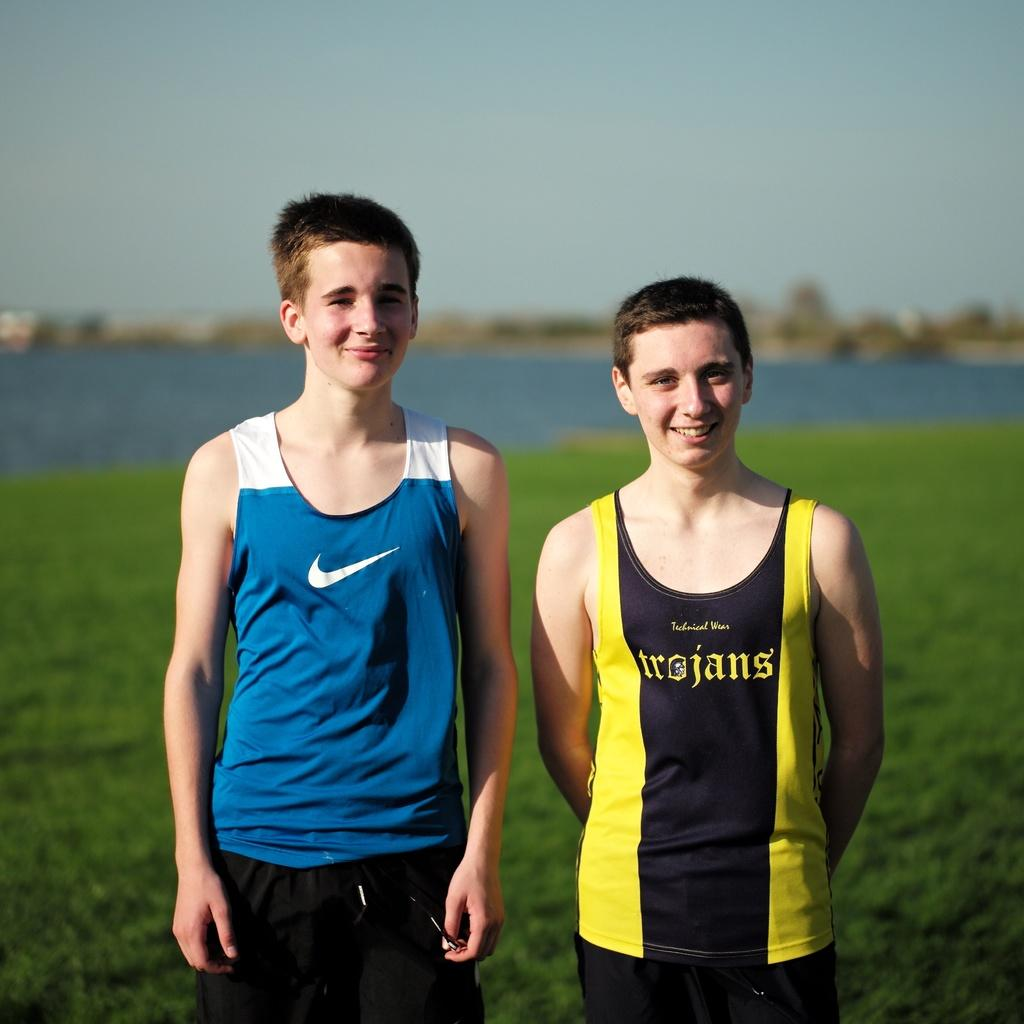<image>
Write a terse but informative summary of the picture. Two young man stand together, one of them having the word trojans on their shirt. 